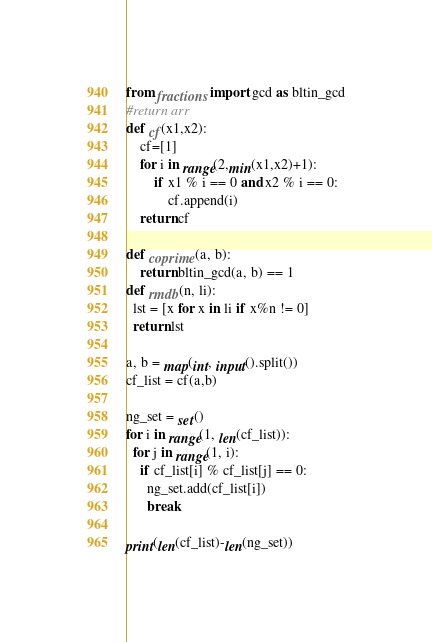<code> <loc_0><loc_0><loc_500><loc_500><_Python_>from fractions import gcd as bltin_gcd
#return arr
def cf(x1,x2):
    cf=[1]
    for i in range(2,min(x1,x2)+1):
        if x1 % i == 0 and x2 % i == 0:
            cf.append(i)
    return cf

def coprime(a, b):
    return bltin_gcd(a, b) == 1
def rmdb(n, li):
  lst = [x for x in li if x%n != 0]
  return lst

a, b = map(int, input().split())
cf_list = cf(a,b)

ng_set = set()
for i in range(1, len(cf_list)):
  for j in range(1, i):
    if cf_list[i] % cf_list[j] == 0:
      ng_set.add(cf_list[i])
      break
  
print(len(cf_list)-len(ng_set))
</code> 